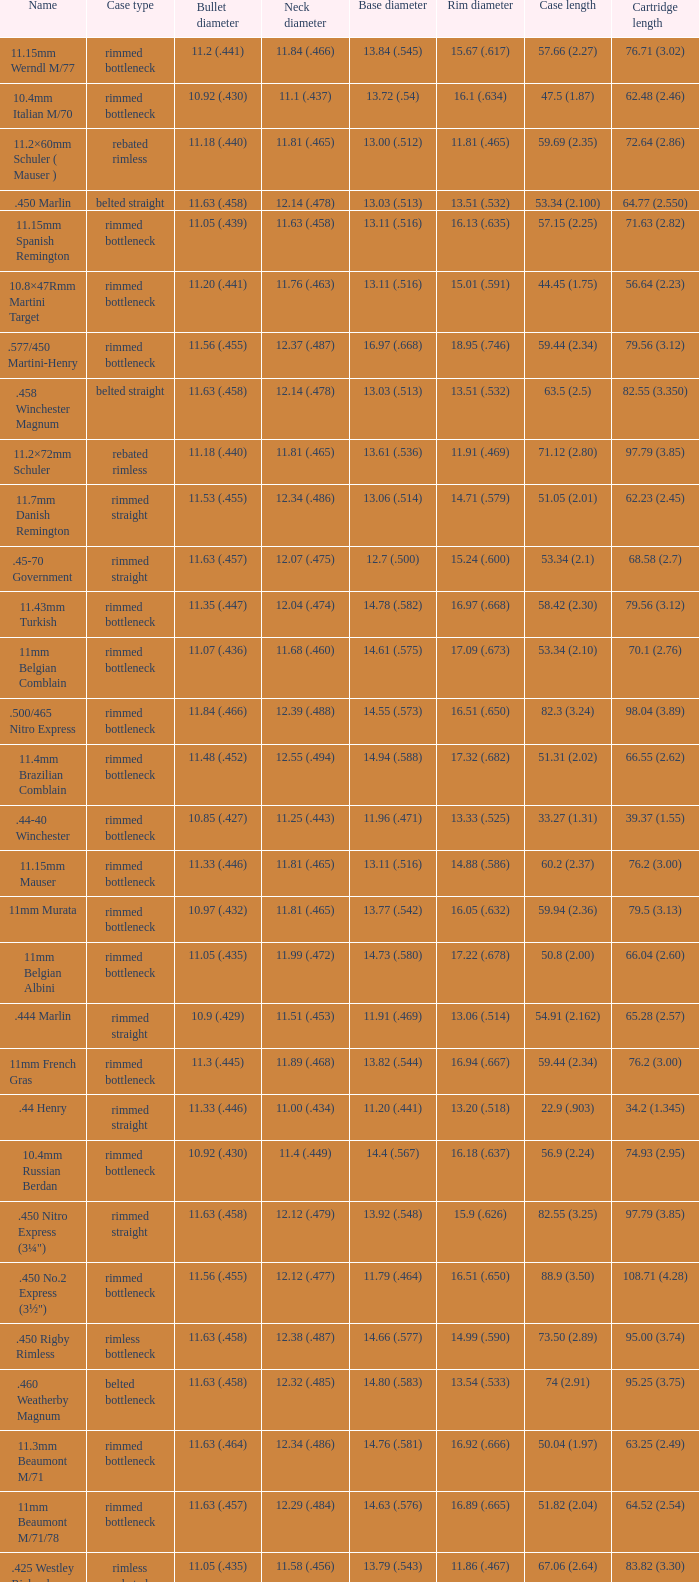Which Case length has a Rim diameter of 13.20 (.518)? 22.9 (.903). 